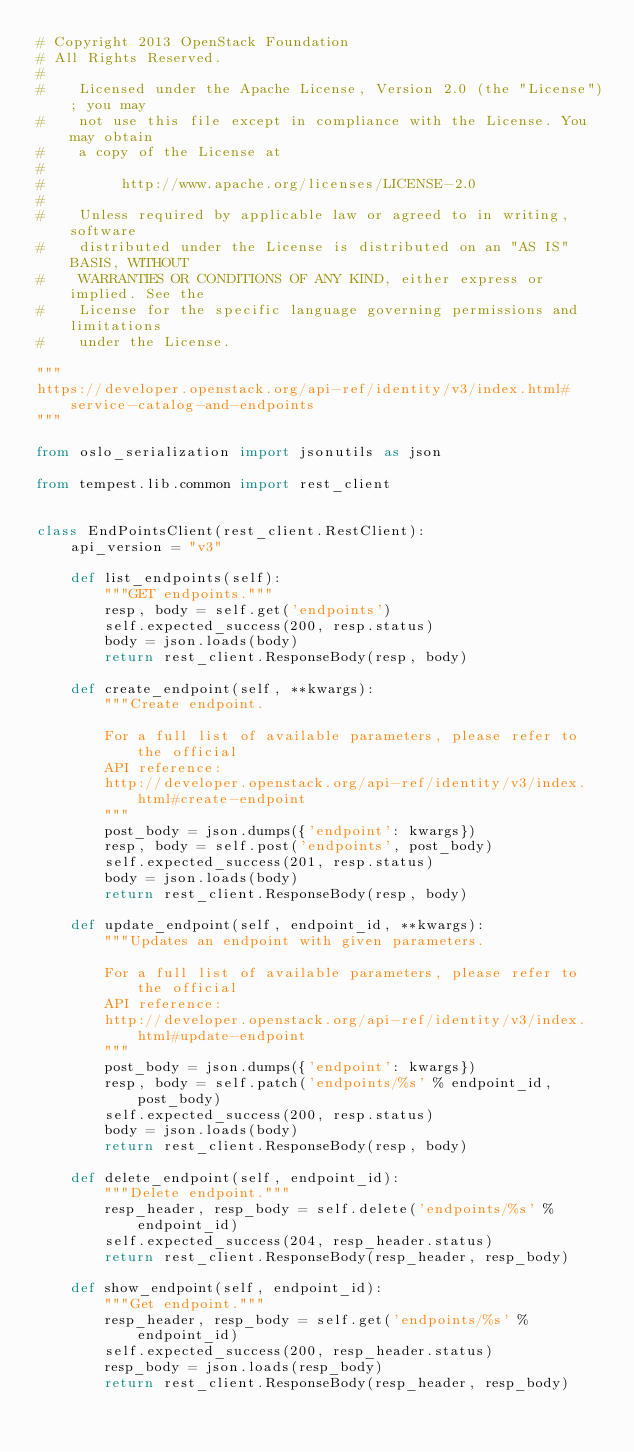<code> <loc_0><loc_0><loc_500><loc_500><_Python_># Copyright 2013 OpenStack Foundation
# All Rights Reserved.
#
#    Licensed under the Apache License, Version 2.0 (the "License"); you may
#    not use this file except in compliance with the License. You may obtain
#    a copy of the License at
#
#         http://www.apache.org/licenses/LICENSE-2.0
#
#    Unless required by applicable law or agreed to in writing, software
#    distributed under the License is distributed on an "AS IS" BASIS, WITHOUT
#    WARRANTIES OR CONDITIONS OF ANY KIND, either express or implied. See the
#    License for the specific language governing permissions and limitations
#    under the License.

"""
https://developer.openstack.org/api-ref/identity/v3/index.html#service-catalog-and-endpoints
"""

from oslo_serialization import jsonutils as json

from tempest.lib.common import rest_client


class EndPointsClient(rest_client.RestClient):
    api_version = "v3"

    def list_endpoints(self):
        """GET endpoints."""
        resp, body = self.get('endpoints')
        self.expected_success(200, resp.status)
        body = json.loads(body)
        return rest_client.ResponseBody(resp, body)

    def create_endpoint(self, **kwargs):
        """Create endpoint.

        For a full list of available parameters, please refer to the official
        API reference:
        http://developer.openstack.org/api-ref/identity/v3/index.html#create-endpoint
        """
        post_body = json.dumps({'endpoint': kwargs})
        resp, body = self.post('endpoints', post_body)
        self.expected_success(201, resp.status)
        body = json.loads(body)
        return rest_client.ResponseBody(resp, body)

    def update_endpoint(self, endpoint_id, **kwargs):
        """Updates an endpoint with given parameters.

        For a full list of available parameters, please refer to the official
        API reference:
        http://developer.openstack.org/api-ref/identity/v3/index.html#update-endpoint
        """
        post_body = json.dumps({'endpoint': kwargs})
        resp, body = self.patch('endpoints/%s' % endpoint_id, post_body)
        self.expected_success(200, resp.status)
        body = json.loads(body)
        return rest_client.ResponseBody(resp, body)

    def delete_endpoint(self, endpoint_id):
        """Delete endpoint."""
        resp_header, resp_body = self.delete('endpoints/%s' % endpoint_id)
        self.expected_success(204, resp_header.status)
        return rest_client.ResponseBody(resp_header, resp_body)

    def show_endpoint(self, endpoint_id):
        """Get endpoint."""
        resp_header, resp_body = self.get('endpoints/%s' % endpoint_id)
        self.expected_success(200, resp_header.status)
        resp_body = json.loads(resp_body)
        return rest_client.ResponseBody(resp_header, resp_body)
</code> 